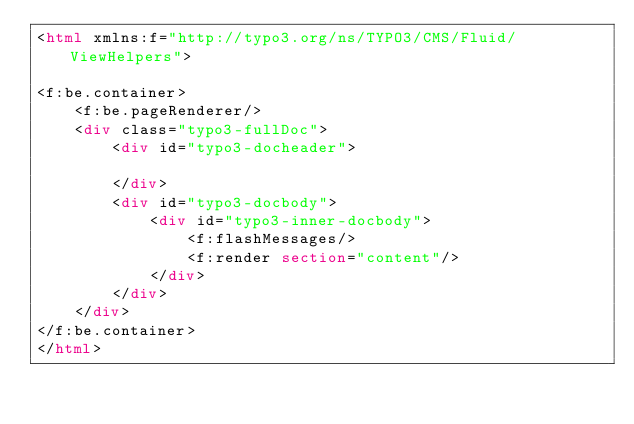<code> <loc_0><loc_0><loc_500><loc_500><_HTML_><html xmlns:f="http://typo3.org/ns/TYPO3/CMS/Fluid/ViewHelpers">

<f:be.container>
	<f:be.pageRenderer/>
	<div class="typo3-fullDoc">
		<div id="typo3-docheader">

		</div>
		<div id="typo3-docbody">
			<div id="typo3-inner-docbody">
				<f:flashMessages/>
				<f:render section="content"/>
			</div>
		</div>
	</div>
</f:be.container>
</html></code> 